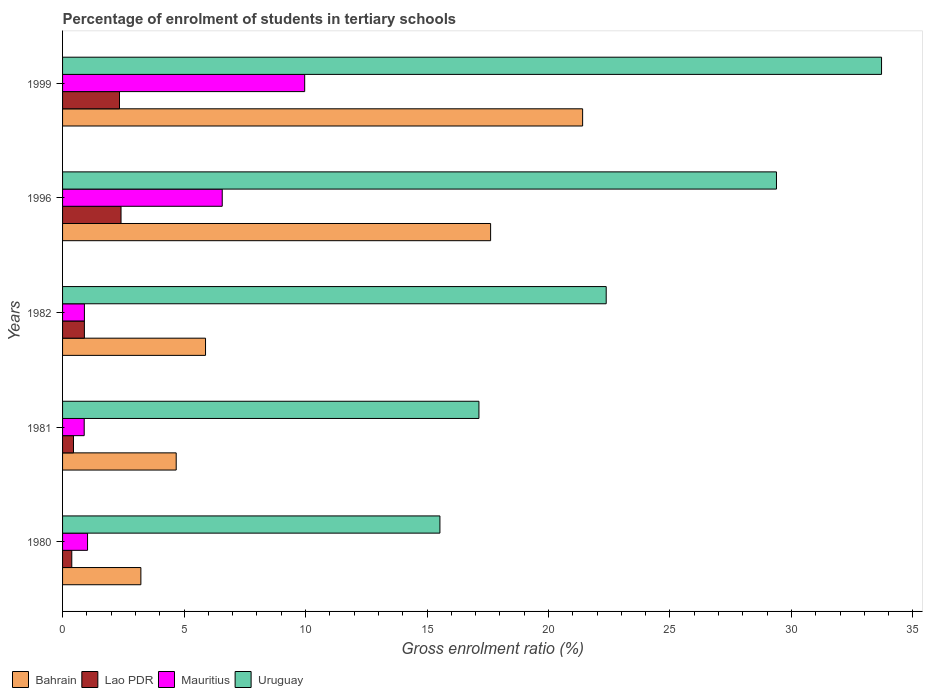How many different coloured bars are there?
Offer a terse response. 4. How many groups of bars are there?
Ensure brevity in your answer.  5. How many bars are there on the 1st tick from the top?
Provide a short and direct response. 4. How many bars are there on the 3rd tick from the bottom?
Keep it short and to the point. 4. What is the label of the 1st group of bars from the top?
Keep it short and to the point. 1999. What is the percentage of students enrolled in tertiary schools in Lao PDR in 1982?
Your answer should be compact. 0.9. Across all years, what is the maximum percentage of students enrolled in tertiary schools in Mauritius?
Offer a terse response. 9.97. Across all years, what is the minimum percentage of students enrolled in tertiary schools in Uruguay?
Offer a terse response. 15.53. In which year was the percentage of students enrolled in tertiary schools in Uruguay maximum?
Offer a terse response. 1999. In which year was the percentage of students enrolled in tertiary schools in Mauritius minimum?
Offer a terse response. 1981. What is the total percentage of students enrolled in tertiary schools in Mauritius in the graph?
Give a very brief answer. 19.36. What is the difference between the percentage of students enrolled in tertiary schools in Lao PDR in 1982 and that in 1999?
Give a very brief answer. -1.44. What is the difference between the percentage of students enrolled in tertiary schools in Uruguay in 1980 and the percentage of students enrolled in tertiary schools in Mauritius in 1996?
Your answer should be compact. 8.96. What is the average percentage of students enrolled in tertiary schools in Uruguay per year?
Ensure brevity in your answer.  23.63. In the year 1980, what is the difference between the percentage of students enrolled in tertiary schools in Lao PDR and percentage of students enrolled in tertiary schools in Uruguay?
Keep it short and to the point. -15.15. In how many years, is the percentage of students enrolled in tertiary schools in Lao PDR greater than 31 %?
Your answer should be compact. 0. What is the ratio of the percentage of students enrolled in tertiary schools in Mauritius in 1981 to that in 1999?
Keep it short and to the point. 0.09. Is the percentage of students enrolled in tertiary schools in Uruguay in 1982 less than that in 1999?
Your answer should be compact. Yes. Is the difference between the percentage of students enrolled in tertiary schools in Lao PDR in 1982 and 1996 greater than the difference between the percentage of students enrolled in tertiary schools in Uruguay in 1982 and 1996?
Provide a short and direct response. Yes. What is the difference between the highest and the second highest percentage of students enrolled in tertiary schools in Mauritius?
Your answer should be compact. 3.39. What is the difference between the highest and the lowest percentage of students enrolled in tertiary schools in Mauritius?
Offer a terse response. 9.07. In how many years, is the percentage of students enrolled in tertiary schools in Lao PDR greater than the average percentage of students enrolled in tertiary schools in Lao PDR taken over all years?
Provide a short and direct response. 2. Is the sum of the percentage of students enrolled in tertiary schools in Uruguay in 1982 and 1999 greater than the maximum percentage of students enrolled in tertiary schools in Lao PDR across all years?
Keep it short and to the point. Yes. Is it the case that in every year, the sum of the percentage of students enrolled in tertiary schools in Bahrain and percentage of students enrolled in tertiary schools in Mauritius is greater than the sum of percentage of students enrolled in tertiary schools in Uruguay and percentage of students enrolled in tertiary schools in Lao PDR?
Keep it short and to the point. No. What does the 2nd bar from the top in 1996 represents?
Offer a very short reply. Mauritius. What does the 3rd bar from the bottom in 1981 represents?
Keep it short and to the point. Mauritius. Is it the case that in every year, the sum of the percentage of students enrolled in tertiary schools in Uruguay and percentage of students enrolled in tertiary schools in Mauritius is greater than the percentage of students enrolled in tertiary schools in Lao PDR?
Offer a very short reply. Yes. Are all the bars in the graph horizontal?
Give a very brief answer. Yes. What is the difference between two consecutive major ticks on the X-axis?
Provide a short and direct response. 5. Does the graph contain any zero values?
Keep it short and to the point. No. Where does the legend appear in the graph?
Keep it short and to the point. Bottom left. What is the title of the graph?
Keep it short and to the point. Percentage of enrolment of students in tertiary schools. What is the label or title of the X-axis?
Provide a short and direct response. Gross enrolment ratio (%). What is the label or title of the Y-axis?
Your response must be concise. Years. What is the Gross enrolment ratio (%) in Bahrain in 1980?
Provide a succinct answer. 3.22. What is the Gross enrolment ratio (%) in Lao PDR in 1980?
Give a very brief answer. 0.38. What is the Gross enrolment ratio (%) of Mauritius in 1980?
Give a very brief answer. 1.03. What is the Gross enrolment ratio (%) in Uruguay in 1980?
Provide a short and direct response. 15.53. What is the Gross enrolment ratio (%) of Bahrain in 1981?
Provide a succinct answer. 4.68. What is the Gross enrolment ratio (%) in Lao PDR in 1981?
Provide a succinct answer. 0.45. What is the Gross enrolment ratio (%) of Mauritius in 1981?
Ensure brevity in your answer.  0.89. What is the Gross enrolment ratio (%) of Uruguay in 1981?
Give a very brief answer. 17.14. What is the Gross enrolment ratio (%) in Bahrain in 1982?
Offer a very short reply. 5.88. What is the Gross enrolment ratio (%) of Lao PDR in 1982?
Ensure brevity in your answer.  0.9. What is the Gross enrolment ratio (%) of Mauritius in 1982?
Your answer should be very brief. 0.9. What is the Gross enrolment ratio (%) in Uruguay in 1982?
Your response must be concise. 22.38. What is the Gross enrolment ratio (%) in Bahrain in 1996?
Give a very brief answer. 17.62. What is the Gross enrolment ratio (%) of Lao PDR in 1996?
Keep it short and to the point. 2.41. What is the Gross enrolment ratio (%) in Mauritius in 1996?
Your answer should be compact. 6.57. What is the Gross enrolment ratio (%) of Uruguay in 1996?
Offer a very short reply. 29.38. What is the Gross enrolment ratio (%) in Bahrain in 1999?
Provide a succinct answer. 21.41. What is the Gross enrolment ratio (%) of Lao PDR in 1999?
Provide a short and direct response. 2.34. What is the Gross enrolment ratio (%) in Mauritius in 1999?
Provide a short and direct response. 9.97. What is the Gross enrolment ratio (%) in Uruguay in 1999?
Your response must be concise. 33.71. Across all years, what is the maximum Gross enrolment ratio (%) in Bahrain?
Provide a succinct answer. 21.41. Across all years, what is the maximum Gross enrolment ratio (%) in Lao PDR?
Offer a very short reply. 2.41. Across all years, what is the maximum Gross enrolment ratio (%) of Mauritius?
Give a very brief answer. 9.97. Across all years, what is the maximum Gross enrolment ratio (%) in Uruguay?
Provide a short and direct response. 33.71. Across all years, what is the minimum Gross enrolment ratio (%) in Bahrain?
Your answer should be very brief. 3.22. Across all years, what is the minimum Gross enrolment ratio (%) of Lao PDR?
Provide a short and direct response. 0.38. Across all years, what is the minimum Gross enrolment ratio (%) in Mauritius?
Make the answer very short. 0.89. Across all years, what is the minimum Gross enrolment ratio (%) in Uruguay?
Keep it short and to the point. 15.53. What is the total Gross enrolment ratio (%) of Bahrain in the graph?
Provide a succinct answer. 52.81. What is the total Gross enrolment ratio (%) in Lao PDR in the graph?
Keep it short and to the point. 6.48. What is the total Gross enrolment ratio (%) of Mauritius in the graph?
Provide a short and direct response. 19.36. What is the total Gross enrolment ratio (%) in Uruguay in the graph?
Your response must be concise. 118.14. What is the difference between the Gross enrolment ratio (%) of Bahrain in 1980 and that in 1981?
Your answer should be very brief. -1.45. What is the difference between the Gross enrolment ratio (%) in Lao PDR in 1980 and that in 1981?
Ensure brevity in your answer.  -0.07. What is the difference between the Gross enrolment ratio (%) in Mauritius in 1980 and that in 1981?
Offer a very short reply. 0.14. What is the difference between the Gross enrolment ratio (%) of Uruguay in 1980 and that in 1981?
Offer a very short reply. -1.61. What is the difference between the Gross enrolment ratio (%) of Bahrain in 1980 and that in 1982?
Your answer should be very brief. -2.66. What is the difference between the Gross enrolment ratio (%) in Lao PDR in 1980 and that in 1982?
Provide a succinct answer. -0.52. What is the difference between the Gross enrolment ratio (%) of Mauritius in 1980 and that in 1982?
Your response must be concise. 0.13. What is the difference between the Gross enrolment ratio (%) of Uruguay in 1980 and that in 1982?
Your answer should be very brief. -6.84. What is the difference between the Gross enrolment ratio (%) of Bahrain in 1980 and that in 1996?
Offer a very short reply. -14.4. What is the difference between the Gross enrolment ratio (%) in Lao PDR in 1980 and that in 1996?
Offer a very short reply. -2.03. What is the difference between the Gross enrolment ratio (%) of Mauritius in 1980 and that in 1996?
Give a very brief answer. -5.54. What is the difference between the Gross enrolment ratio (%) of Uruguay in 1980 and that in 1996?
Make the answer very short. -13.85. What is the difference between the Gross enrolment ratio (%) of Bahrain in 1980 and that in 1999?
Give a very brief answer. -18.18. What is the difference between the Gross enrolment ratio (%) of Lao PDR in 1980 and that in 1999?
Provide a short and direct response. -1.96. What is the difference between the Gross enrolment ratio (%) of Mauritius in 1980 and that in 1999?
Offer a very short reply. -8.94. What is the difference between the Gross enrolment ratio (%) of Uruguay in 1980 and that in 1999?
Your answer should be very brief. -18.18. What is the difference between the Gross enrolment ratio (%) in Bahrain in 1981 and that in 1982?
Offer a terse response. -1.21. What is the difference between the Gross enrolment ratio (%) in Lao PDR in 1981 and that in 1982?
Your response must be concise. -0.45. What is the difference between the Gross enrolment ratio (%) in Mauritius in 1981 and that in 1982?
Your response must be concise. -0.01. What is the difference between the Gross enrolment ratio (%) in Uruguay in 1981 and that in 1982?
Your answer should be very brief. -5.24. What is the difference between the Gross enrolment ratio (%) of Bahrain in 1981 and that in 1996?
Offer a terse response. -12.94. What is the difference between the Gross enrolment ratio (%) in Lao PDR in 1981 and that in 1996?
Ensure brevity in your answer.  -1.96. What is the difference between the Gross enrolment ratio (%) of Mauritius in 1981 and that in 1996?
Your response must be concise. -5.68. What is the difference between the Gross enrolment ratio (%) in Uruguay in 1981 and that in 1996?
Keep it short and to the point. -12.25. What is the difference between the Gross enrolment ratio (%) in Bahrain in 1981 and that in 1999?
Your answer should be compact. -16.73. What is the difference between the Gross enrolment ratio (%) of Lao PDR in 1981 and that in 1999?
Your answer should be very brief. -1.89. What is the difference between the Gross enrolment ratio (%) in Mauritius in 1981 and that in 1999?
Your response must be concise. -9.07. What is the difference between the Gross enrolment ratio (%) in Uruguay in 1981 and that in 1999?
Keep it short and to the point. -16.57. What is the difference between the Gross enrolment ratio (%) of Bahrain in 1982 and that in 1996?
Your answer should be very brief. -11.73. What is the difference between the Gross enrolment ratio (%) of Lao PDR in 1982 and that in 1996?
Offer a very short reply. -1.51. What is the difference between the Gross enrolment ratio (%) in Mauritius in 1982 and that in 1996?
Your answer should be compact. -5.67. What is the difference between the Gross enrolment ratio (%) in Uruguay in 1982 and that in 1996?
Give a very brief answer. -7.01. What is the difference between the Gross enrolment ratio (%) in Bahrain in 1982 and that in 1999?
Your response must be concise. -15.52. What is the difference between the Gross enrolment ratio (%) of Lao PDR in 1982 and that in 1999?
Your response must be concise. -1.44. What is the difference between the Gross enrolment ratio (%) in Mauritius in 1982 and that in 1999?
Your answer should be compact. -9.07. What is the difference between the Gross enrolment ratio (%) of Uruguay in 1982 and that in 1999?
Give a very brief answer. -11.33. What is the difference between the Gross enrolment ratio (%) of Bahrain in 1996 and that in 1999?
Provide a short and direct response. -3.79. What is the difference between the Gross enrolment ratio (%) in Lao PDR in 1996 and that in 1999?
Give a very brief answer. 0.06. What is the difference between the Gross enrolment ratio (%) in Mauritius in 1996 and that in 1999?
Provide a short and direct response. -3.39. What is the difference between the Gross enrolment ratio (%) in Uruguay in 1996 and that in 1999?
Give a very brief answer. -4.32. What is the difference between the Gross enrolment ratio (%) in Bahrain in 1980 and the Gross enrolment ratio (%) in Lao PDR in 1981?
Provide a succinct answer. 2.77. What is the difference between the Gross enrolment ratio (%) of Bahrain in 1980 and the Gross enrolment ratio (%) of Mauritius in 1981?
Your response must be concise. 2.33. What is the difference between the Gross enrolment ratio (%) of Bahrain in 1980 and the Gross enrolment ratio (%) of Uruguay in 1981?
Provide a succinct answer. -13.92. What is the difference between the Gross enrolment ratio (%) in Lao PDR in 1980 and the Gross enrolment ratio (%) in Mauritius in 1981?
Offer a very short reply. -0.51. What is the difference between the Gross enrolment ratio (%) of Lao PDR in 1980 and the Gross enrolment ratio (%) of Uruguay in 1981?
Your answer should be very brief. -16.76. What is the difference between the Gross enrolment ratio (%) in Mauritius in 1980 and the Gross enrolment ratio (%) in Uruguay in 1981?
Provide a succinct answer. -16.11. What is the difference between the Gross enrolment ratio (%) of Bahrain in 1980 and the Gross enrolment ratio (%) of Lao PDR in 1982?
Offer a very short reply. 2.32. What is the difference between the Gross enrolment ratio (%) of Bahrain in 1980 and the Gross enrolment ratio (%) of Mauritius in 1982?
Ensure brevity in your answer.  2.32. What is the difference between the Gross enrolment ratio (%) in Bahrain in 1980 and the Gross enrolment ratio (%) in Uruguay in 1982?
Ensure brevity in your answer.  -19.15. What is the difference between the Gross enrolment ratio (%) of Lao PDR in 1980 and the Gross enrolment ratio (%) of Mauritius in 1982?
Keep it short and to the point. -0.52. What is the difference between the Gross enrolment ratio (%) of Lao PDR in 1980 and the Gross enrolment ratio (%) of Uruguay in 1982?
Provide a short and direct response. -22. What is the difference between the Gross enrolment ratio (%) of Mauritius in 1980 and the Gross enrolment ratio (%) of Uruguay in 1982?
Provide a succinct answer. -21.35. What is the difference between the Gross enrolment ratio (%) in Bahrain in 1980 and the Gross enrolment ratio (%) in Lao PDR in 1996?
Give a very brief answer. 0.82. What is the difference between the Gross enrolment ratio (%) of Bahrain in 1980 and the Gross enrolment ratio (%) of Mauritius in 1996?
Offer a very short reply. -3.35. What is the difference between the Gross enrolment ratio (%) of Bahrain in 1980 and the Gross enrolment ratio (%) of Uruguay in 1996?
Your answer should be very brief. -26.16. What is the difference between the Gross enrolment ratio (%) in Lao PDR in 1980 and the Gross enrolment ratio (%) in Mauritius in 1996?
Your response must be concise. -6.19. What is the difference between the Gross enrolment ratio (%) of Lao PDR in 1980 and the Gross enrolment ratio (%) of Uruguay in 1996?
Your response must be concise. -29. What is the difference between the Gross enrolment ratio (%) of Mauritius in 1980 and the Gross enrolment ratio (%) of Uruguay in 1996?
Make the answer very short. -28.36. What is the difference between the Gross enrolment ratio (%) in Bahrain in 1980 and the Gross enrolment ratio (%) in Lao PDR in 1999?
Provide a short and direct response. 0.88. What is the difference between the Gross enrolment ratio (%) of Bahrain in 1980 and the Gross enrolment ratio (%) of Mauritius in 1999?
Ensure brevity in your answer.  -6.74. What is the difference between the Gross enrolment ratio (%) of Bahrain in 1980 and the Gross enrolment ratio (%) of Uruguay in 1999?
Offer a terse response. -30.49. What is the difference between the Gross enrolment ratio (%) in Lao PDR in 1980 and the Gross enrolment ratio (%) in Mauritius in 1999?
Make the answer very short. -9.59. What is the difference between the Gross enrolment ratio (%) of Lao PDR in 1980 and the Gross enrolment ratio (%) of Uruguay in 1999?
Provide a short and direct response. -33.33. What is the difference between the Gross enrolment ratio (%) of Mauritius in 1980 and the Gross enrolment ratio (%) of Uruguay in 1999?
Ensure brevity in your answer.  -32.68. What is the difference between the Gross enrolment ratio (%) of Bahrain in 1981 and the Gross enrolment ratio (%) of Lao PDR in 1982?
Provide a succinct answer. 3.78. What is the difference between the Gross enrolment ratio (%) of Bahrain in 1981 and the Gross enrolment ratio (%) of Mauritius in 1982?
Provide a short and direct response. 3.78. What is the difference between the Gross enrolment ratio (%) of Bahrain in 1981 and the Gross enrolment ratio (%) of Uruguay in 1982?
Offer a very short reply. -17.7. What is the difference between the Gross enrolment ratio (%) of Lao PDR in 1981 and the Gross enrolment ratio (%) of Mauritius in 1982?
Your answer should be compact. -0.45. What is the difference between the Gross enrolment ratio (%) in Lao PDR in 1981 and the Gross enrolment ratio (%) in Uruguay in 1982?
Your response must be concise. -21.93. What is the difference between the Gross enrolment ratio (%) of Mauritius in 1981 and the Gross enrolment ratio (%) of Uruguay in 1982?
Offer a very short reply. -21.49. What is the difference between the Gross enrolment ratio (%) of Bahrain in 1981 and the Gross enrolment ratio (%) of Lao PDR in 1996?
Your answer should be compact. 2.27. What is the difference between the Gross enrolment ratio (%) of Bahrain in 1981 and the Gross enrolment ratio (%) of Mauritius in 1996?
Ensure brevity in your answer.  -1.89. What is the difference between the Gross enrolment ratio (%) in Bahrain in 1981 and the Gross enrolment ratio (%) in Uruguay in 1996?
Offer a terse response. -24.71. What is the difference between the Gross enrolment ratio (%) in Lao PDR in 1981 and the Gross enrolment ratio (%) in Mauritius in 1996?
Ensure brevity in your answer.  -6.12. What is the difference between the Gross enrolment ratio (%) in Lao PDR in 1981 and the Gross enrolment ratio (%) in Uruguay in 1996?
Provide a short and direct response. -28.93. What is the difference between the Gross enrolment ratio (%) in Mauritius in 1981 and the Gross enrolment ratio (%) in Uruguay in 1996?
Offer a terse response. -28.49. What is the difference between the Gross enrolment ratio (%) of Bahrain in 1981 and the Gross enrolment ratio (%) of Lao PDR in 1999?
Offer a very short reply. 2.33. What is the difference between the Gross enrolment ratio (%) in Bahrain in 1981 and the Gross enrolment ratio (%) in Mauritius in 1999?
Offer a very short reply. -5.29. What is the difference between the Gross enrolment ratio (%) in Bahrain in 1981 and the Gross enrolment ratio (%) in Uruguay in 1999?
Give a very brief answer. -29.03. What is the difference between the Gross enrolment ratio (%) of Lao PDR in 1981 and the Gross enrolment ratio (%) of Mauritius in 1999?
Give a very brief answer. -9.52. What is the difference between the Gross enrolment ratio (%) of Lao PDR in 1981 and the Gross enrolment ratio (%) of Uruguay in 1999?
Your answer should be compact. -33.26. What is the difference between the Gross enrolment ratio (%) in Mauritius in 1981 and the Gross enrolment ratio (%) in Uruguay in 1999?
Make the answer very short. -32.82. What is the difference between the Gross enrolment ratio (%) of Bahrain in 1982 and the Gross enrolment ratio (%) of Lao PDR in 1996?
Your answer should be compact. 3.48. What is the difference between the Gross enrolment ratio (%) in Bahrain in 1982 and the Gross enrolment ratio (%) in Mauritius in 1996?
Keep it short and to the point. -0.69. What is the difference between the Gross enrolment ratio (%) in Bahrain in 1982 and the Gross enrolment ratio (%) in Uruguay in 1996?
Offer a very short reply. -23.5. What is the difference between the Gross enrolment ratio (%) of Lao PDR in 1982 and the Gross enrolment ratio (%) of Mauritius in 1996?
Offer a very short reply. -5.67. What is the difference between the Gross enrolment ratio (%) of Lao PDR in 1982 and the Gross enrolment ratio (%) of Uruguay in 1996?
Provide a short and direct response. -28.49. What is the difference between the Gross enrolment ratio (%) of Mauritius in 1982 and the Gross enrolment ratio (%) of Uruguay in 1996?
Your answer should be very brief. -28.49. What is the difference between the Gross enrolment ratio (%) of Bahrain in 1982 and the Gross enrolment ratio (%) of Lao PDR in 1999?
Your answer should be compact. 3.54. What is the difference between the Gross enrolment ratio (%) in Bahrain in 1982 and the Gross enrolment ratio (%) in Mauritius in 1999?
Your answer should be compact. -4.08. What is the difference between the Gross enrolment ratio (%) of Bahrain in 1982 and the Gross enrolment ratio (%) of Uruguay in 1999?
Your answer should be very brief. -27.82. What is the difference between the Gross enrolment ratio (%) of Lao PDR in 1982 and the Gross enrolment ratio (%) of Mauritius in 1999?
Your response must be concise. -9.07. What is the difference between the Gross enrolment ratio (%) of Lao PDR in 1982 and the Gross enrolment ratio (%) of Uruguay in 1999?
Give a very brief answer. -32.81. What is the difference between the Gross enrolment ratio (%) in Mauritius in 1982 and the Gross enrolment ratio (%) in Uruguay in 1999?
Ensure brevity in your answer.  -32.81. What is the difference between the Gross enrolment ratio (%) of Bahrain in 1996 and the Gross enrolment ratio (%) of Lao PDR in 1999?
Provide a succinct answer. 15.27. What is the difference between the Gross enrolment ratio (%) of Bahrain in 1996 and the Gross enrolment ratio (%) of Mauritius in 1999?
Provide a short and direct response. 7.65. What is the difference between the Gross enrolment ratio (%) in Bahrain in 1996 and the Gross enrolment ratio (%) in Uruguay in 1999?
Provide a succinct answer. -16.09. What is the difference between the Gross enrolment ratio (%) of Lao PDR in 1996 and the Gross enrolment ratio (%) of Mauritius in 1999?
Provide a succinct answer. -7.56. What is the difference between the Gross enrolment ratio (%) of Lao PDR in 1996 and the Gross enrolment ratio (%) of Uruguay in 1999?
Your answer should be compact. -31.3. What is the difference between the Gross enrolment ratio (%) of Mauritius in 1996 and the Gross enrolment ratio (%) of Uruguay in 1999?
Offer a terse response. -27.14. What is the average Gross enrolment ratio (%) in Bahrain per year?
Your response must be concise. 10.56. What is the average Gross enrolment ratio (%) in Lao PDR per year?
Provide a succinct answer. 1.3. What is the average Gross enrolment ratio (%) of Mauritius per year?
Offer a very short reply. 3.87. What is the average Gross enrolment ratio (%) of Uruguay per year?
Give a very brief answer. 23.63. In the year 1980, what is the difference between the Gross enrolment ratio (%) of Bahrain and Gross enrolment ratio (%) of Lao PDR?
Offer a very short reply. 2.84. In the year 1980, what is the difference between the Gross enrolment ratio (%) in Bahrain and Gross enrolment ratio (%) in Mauritius?
Offer a very short reply. 2.19. In the year 1980, what is the difference between the Gross enrolment ratio (%) of Bahrain and Gross enrolment ratio (%) of Uruguay?
Provide a short and direct response. -12.31. In the year 1980, what is the difference between the Gross enrolment ratio (%) of Lao PDR and Gross enrolment ratio (%) of Mauritius?
Give a very brief answer. -0.65. In the year 1980, what is the difference between the Gross enrolment ratio (%) of Lao PDR and Gross enrolment ratio (%) of Uruguay?
Ensure brevity in your answer.  -15.15. In the year 1980, what is the difference between the Gross enrolment ratio (%) in Mauritius and Gross enrolment ratio (%) in Uruguay?
Offer a very short reply. -14.5. In the year 1981, what is the difference between the Gross enrolment ratio (%) in Bahrain and Gross enrolment ratio (%) in Lao PDR?
Your answer should be very brief. 4.23. In the year 1981, what is the difference between the Gross enrolment ratio (%) of Bahrain and Gross enrolment ratio (%) of Mauritius?
Your response must be concise. 3.79. In the year 1981, what is the difference between the Gross enrolment ratio (%) in Bahrain and Gross enrolment ratio (%) in Uruguay?
Offer a very short reply. -12.46. In the year 1981, what is the difference between the Gross enrolment ratio (%) of Lao PDR and Gross enrolment ratio (%) of Mauritius?
Make the answer very short. -0.44. In the year 1981, what is the difference between the Gross enrolment ratio (%) of Lao PDR and Gross enrolment ratio (%) of Uruguay?
Provide a short and direct response. -16.69. In the year 1981, what is the difference between the Gross enrolment ratio (%) in Mauritius and Gross enrolment ratio (%) in Uruguay?
Offer a very short reply. -16.25. In the year 1982, what is the difference between the Gross enrolment ratio (%) of Bahrain and Gross enrolment ratio (%) of Lao PDR?
Ensure brevity in your answer.  4.99. In the year 1982, what is the difference between the Gross enrolment ratio (%) in Bahrain and Gross enrolment ratio (%) in Mauritius?
Offer a terse response. 4.99. In the year 1982, what is the difference between the Gross enrolment ratio (%) in Bahrain and Gross enrolment ratio (%) in Uruguay?
Your answer should be compact. -16.49. In the year 1982, what is the difference between the Gross enrolment ratio (%) in Lao PDR and Gross enrolment ratio (%) in Mauritius?
Your answer should be very brief. -0. In the year 1982, what is the difference between the Gross enrolment ratio (%) in Lao PDR and Gross enrolment ratio (%) in Uruguay?
Give a very brief answer. -21.48. In the year 1982, what is the difference between the Gross enrolment ratio (%) of Mauritius and Gross enrolment ratio (%) of Uruguay?
Offer a very short reply. -21.48. In the year 1996, what is the difference between the Gross enrolment ratio (%) in Bahrain and Gross enrolment ratio (%) in Lao PDR?
Give a very brief answer. 15.21. In the year 1996, what is the difference between the Gross enrolment ratio (%) in Bahrain and Gross enrolment ratio (%) in Mauritius?
Keep it short and to the point. 11.05. In the year 1996, what is the difference between the Gross enrolment ratio (%) of Bahrain and Gross enrolment ratio (%) of Uruguay?
Provide a short and direct response. -11.77. In the year 1996, what is the difference between the Gross enrolment ratio (%) in Lao PDR and Gross enrolment ratio (%) in Mauritius?
Ensure brevity in your answer.  -4.17. In the year 1996, what is the difference between the Gross enrolment ratio (%) in Lao PDR and Gross enrolment ratio (%) in Uruguay?
Your response must be concise. -26.98. In the year 1996, what is the difference between the Gross enrolment ratio (%) of Mauritius and Gross enrolment ratio (%) of Uruguay?
Provide a succinct answer. -22.81. In the year 1999, what is the difference between the Gross enrolment ratio (%) in Bahrain and Gross enrolment ratio (%) in Lao PDR?
Ensure brevity in your answer.  19.06. In the year 1999, what is the difference between the Gross enrolment ratio (%) of Bahrain and Gross enrolment ratio (%) of Mauritius?
Give a very brief answer. 11.44. In the year 1999, what is the difference between the Gross enrolment ratio (%) of Bahrain and Gross enrolment ratio (%) of Uruguay?
Keep it short and to the point. -12.3. In the year 1999, what is the difference between the Gross enrolment ratio (%) of Lao PDR and Gross enrolment ratio (%) of Mauritius?
Your answer should be very brief. -7.62. In the year 1999, what is the difference between the Gross enrolment ratio (%) in Lao PDR and Gross enrolment ratio (%) in Uruguay?
Give a very brief answer. -31.37. In the year 1999, what is the difference between the Gross enrolment ratio (%) in Mauritius and Gross enrolment ratio (%) in Uruguay?
Your answer should be very brief. -23.74. What is the ratio of the Gross enrolment ratio (%) of Bahrain in 1980 to that in 1981?
Provide a succinct answer. 0.69. What is the ratio of the Gross enrolment ratio (%) of Lao PDR in 1980 to that in 1981?
Make the answer very short. 0.84. What is the ratio of the Gross enrolment ratio (%) in Mauritius in 1980 to that in 1981?
Keep it short and to the point. 1.15. What is the ratio of the Gross enrolment ratio (%) in Uruguay in 1980 to that in 1981?
Make the answer very short. 0.91. What is the ratio of the Gross enrolment ratio (%) of Bahrain in 1980 to that in 1982?
Offer a very short reply. 0.55. What is the ratio of the Gross enrolment ratio (%) of Lao PDR in 1980 to that in 1982?
Offer a very short reply. 0.42. What is the ratio of the Gross enrolment ratio (%) of Mauritius in 1980 to that in 1982?
Your answer should be compact. 1.14. What is the ratio of the Gross enrolment ratio (%) of Uruguay in 1980 to that in 1982?
Make the answer very short. 0.69. What is the ratio of the Gross enrolment ratio (%) in Bahrain in 1980 to that in 1996?
Keep it short and to the point. 0.18. What is the ratio of the Gross enrolment ratio (%) of Lao PDR in 1980 to that in 1996?
Ensure brevity in your answer.  0.16. What is the ratio of the Gross enrolment ratio (%) of Mauritius in 1980 to that in 1996?
Provide a succinct answer. 0.16. What is the ratio of the Gross enrolment ratio (%) in Uruguay in 1980 to that in 1996?
Provide a succinct answer. 0.53. What is the ratio of the Gross enrolment ratio (%) in Bahrain in 1980 to that in 1999?
Give a very brief answer. 0.15. What is the ratio of the Gross enrolment ratio (%) in Lao PDR in 1980 to that in 1999?
Ensure brevity in your answer.  0.16. What is the ratio of the Gross enrolment ratio (%) of Mauritius in 1980 to that in 1999?
Provide a short and direct response. 0.1. What is the ratio of the Gross enrolment ratio (%) of Uruguay in 1980 to that in 1999?
Offer a very short reply. 0.46. What is the ratio of the Gross enrolment ratio (%) in Bahrain in 1981 to that in 1982?
Keep it short and to the point. 0.79. What is the ratio of the Gross enrolment ratio (%) of Lao PDR in 1981 to that in 1982?
Ensure brevity in your answer.  0.5. What is the ratio of the Gross enrolment ratio (%) in Uruguay in 1981 to that in 1982?
Offer a terse response. 0.77. What is the ratio of the Gross enrolment ratio (%) of Bahrain in 1981 to that in 1996?
Give a very brief answer. 0.27. What is the ratio of the Gross enrolment ratio (%) of Lao PDR in 1981 to that in 1996?
Ensure brevity in your answer.  0.19. What is the ratio of the Gross enrolment ratio (%) in Mauritius in 1981 to that in 1996?
Provide a short and direct response. 0.14. What is the ratio of the Gross enrolment ratio (%) of Uruguay in 1981 to that in 1996?
Provide a short and direct response. 0.58. What is the ratio of the Gross enrolment ratio (%) in Bahrain in 1981 to that in 1999?
Give a very brief answer. 0.22. What is the ratio of the Gross enrolment ratio (%) in Lao PDR in 1981 to that in 1999?
Your answer should be very brief. 0.19. What is the ratio of the Gross enrolment ratio (%) of Mauritius in 1981 to that in 1999?
Your answer should be compact. 0.09. What is the ratio of the Gross enrolment ratio (%) in Uruguay in 1981 to that in 1999?
Provide a succinct answer. 0.51. What is the ratio of the Gross enrolment ratio (%) in Bahrain in 1982 to that in 1996?
Provide a short and direct response. 0.33. What is the ratio of the Gross enrolment ratio (%) in Lao PDR in 1982 to that in 1996?
Provide a succinct answer. 0.37. What is the ratio of the Gross enrolment ratio (%) in Mauritius in 1982 to that in 1996?
Offer a terse response. 0.14. What is the ratio of the Gross enrolment ratio (%) in Uruguay in 1982 to that in 1996?
Provide a short and direct response. 0.76. What is the ratio of the Gross enrolment ratio (%) of Bahrain in 1982 to that in 1999?
Keep it short and to the point. 0.27. What is the ratio of the Gross enrolment ratio (%) of Lao PDR in 1982 to that in 1999?
Keep it short and to the point. 0.38. What is the ratio of the Gross enrolment ratio (%) of Mauritius in 1982 to that in 1999?
Give a very brief answer. 0.09. What is the ratio of the Gross enrolment ratio (%) of Uruguay in 1982 to that in 1999?
Your answer should be compact. 0.66. What is the ratio of the Gross enrolment ratio (%) in Bahrain in 1996 to that in 1999?
Offer a very short reply. 0.82. What is the ratio of the Gross enrolment ratio (%) in Lao PDR in 1996 to that in 1999?
Make the answer very short. 1.03. What is the ratio of the Gross enrolment ratio (%) of Mauritius in 1996 to that in 1999?
Your answer should be compact. 0.66. What is the ratio of the Gross enrolment ratio (%) of Uruguay in 1996 to that in 1999?
Your answer should be very brief. 0.87. What is the difference between the highest and the second highest Gross enrolment ratio (%) in Bahrain?
Your answer should be very brief. 3.79. What is the difference between the highest and the second highest Gross enrolment ratio (%) of Lao PDR?
Keep it short and to the point. 0.06. What is the difference between the highest and the second highest Gross enrolment ratio (%) in Mauritius?
Provide a succinct answer. 3.39. What is the difference between the highest and the second highest Gross enrolment ratio (%) in Uruguay?
Ensure brevity in your answer.  4.32. What is the difference between the highest and the lowest Gross enrolment ratio (%) of Bahrain?
Offer a very short reply. 18.18. What is the difference between the highest and the lowest Gross enrolment ratio (%) in Lao PDR?
Provide a succinct answer. 2.03. What is the difference between the highest and the lowest Gross enrolment ratio (%) of Mauritius?
Ensure brevity in your answer.  9.07. What is the difference between the highest and the lowest Gross enrolment ratio (%) of Uruguay?
Your answer should be very brief. 18.18. 